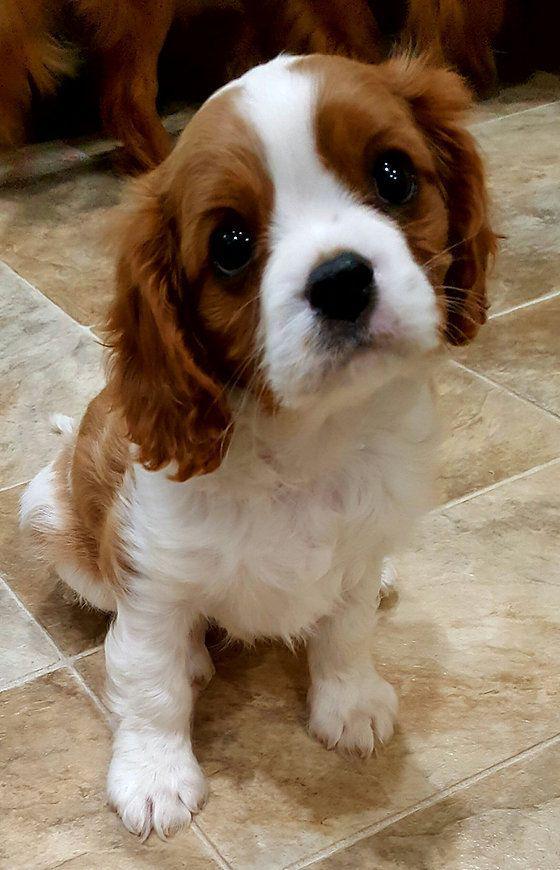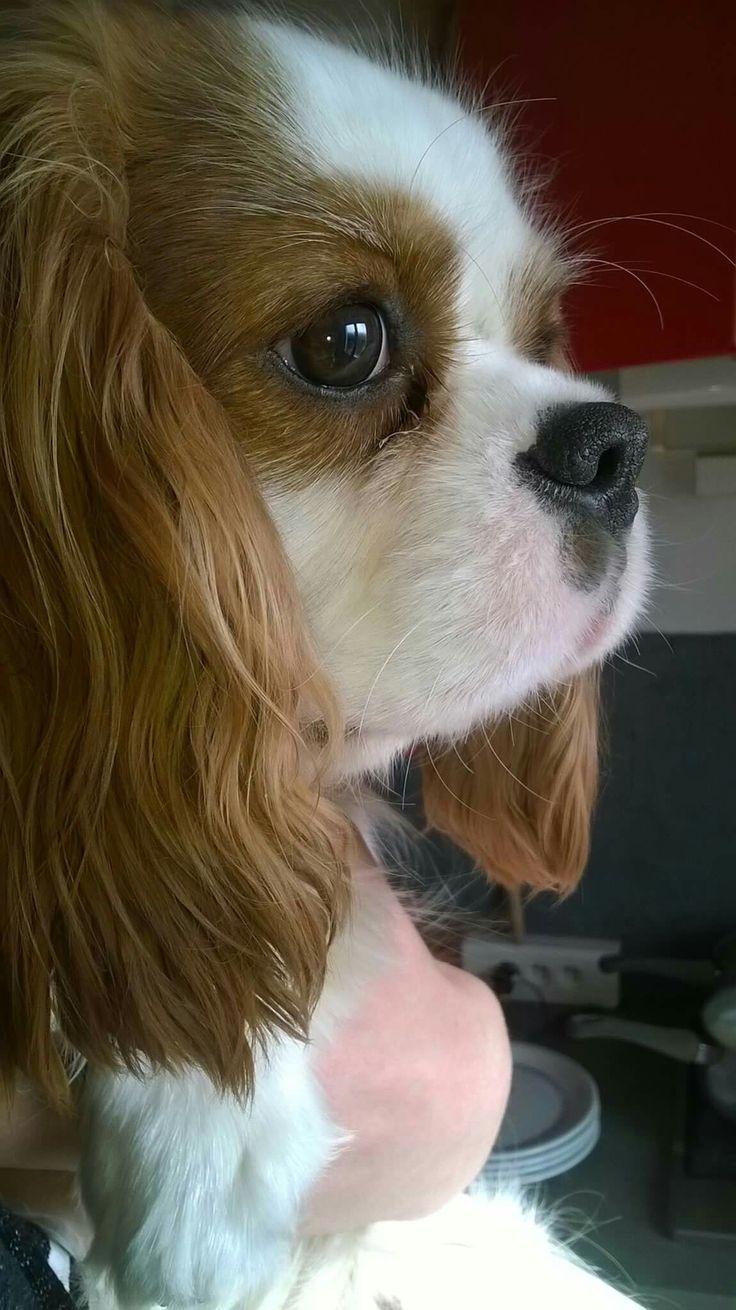The first image is the image on the left, the second image is the image on the right. Given the left and right images, does the statement "There is a single brown and white cocker spaniel looking left." hold true? Answer yes or no. No. 